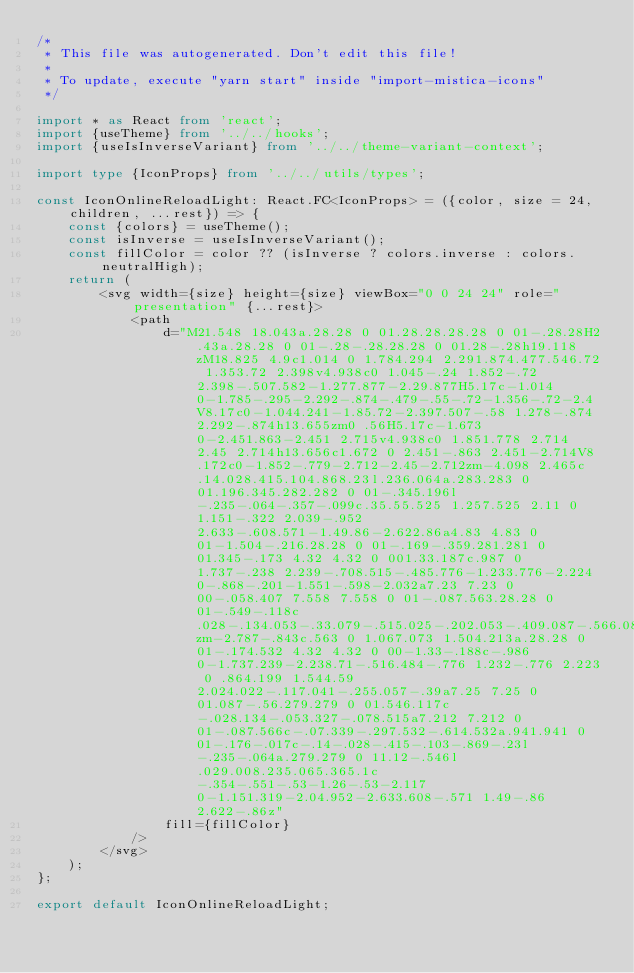Convert code to text. <code><loc_0><loc_0><loc_500><loc_500><_TypeScript_>/*
 * This file was autogenerated. Don't edit this file!
 *
 * To update, execute "yarn start" inside "import-mistica-icons"
 */

import * as React from 'react';
import {useTheme} from '../../hooks';
import {useIsInverseVariant} from '../../theme-variant-context';

import type {IconProps} from '../../utils/types';

const IconOnlineReloadLight: React.FC<IconProps> = ({color, size = 24, children, ...rest}) => {
    const {colors} = useTheme();
    const isInverse = useIsInverseVariant();
    const fillColor = color ?? (isInverse ? colors.inverse : colors.neutralHigh);
    return (
        <svg width={size} height={size} viewBox="0 0 24 24" role="presentation" {...rest}>
            <path
                d="M21.548 18.043a.28.28 0 01.28.28.28.28 0 01-.28.28H2.43a.28.28 0 01-.28-.28.28.28 0 01.28-.28h19.118zM18.825 4.9c1.014 0 1.784.294 2.291.874.477.546.72 1.353.72 2.398v4.938c0 1.045-.24 1.852-.72 2.398-.507.582-1.277.877-2.29.877H5.17c-1.014 0-1.785-.295-2.292-.874-.479-.55-.72-1.356-.72-2.4V8.17c0-1.044.241-1.85.72-2.397.507-.58 1.278-.874 2.292-.874h13.655zm0 .56H5.17c-1.673 0-2.451.863-2.451 2.715v4.938c0 1.851.778 2.714 2.45 2.714h13.656c1.672 0 2.451-.863 2.451-2.714V8.172c0-1.852-.779-2.712-2.45-2.712zm-4.098 2.465c.14.028.415.104.868.23l.236.064a.283.283 0 01.196.345.282.282 0 01-.345.196l-.235-.064-.357-.099c.35.55.525 1.257.525 2.11 0 1.151-.322 2.039-.952 2.633-.608.571-1.49.86-2.622.86a4.83 4.83 0 01-1.504-.216.28.28 0 01-.169-.359.281.281 0 01.345-.173 4.32 4.32 0 001.33.187c.987 0 1.737-.238 2.239-.708.515-.485.776-1.233.776-2.224 0-.868-.201-1.551-.598-2.032a7.23 7.23 0 00-.058.407 7.558 7.558 0 01-.087.563.28.28 0 01-.549-.118c.028-.134.053-.33.079-.515.025-.202.053-.409.087-.566.086-.406.386-.602.795-.52zm-2.787-.843c.563 0 1.067.073 1.504.213a.28.28 0 01-.174.532 4.32 4.32 0 00-1.33-.188c-.986 0-1.737.239-2.238.71-.516.484-.776 1.232-.776 2.223 0 .864.199 1.544.59 2.024.022-.117.041-.255.057-.39a7.25 7.25 0 01.087-.56.279.279 0 01.546.117c-.028.134-.053.327-.078.515a7.212 7.212 0 01-.087.566c-.07.339-.297.532-.614.532a.941.941 0 01-.176-.017c-.14-.028-.415-.103-.869-.23l-.235-.064a.279.279 0 11.12-.546l.029.008.235.065.365.1c-.354-.551-.53-1.26-.53-2.117 0-1.151.319-2.04.952-2.633.608-.571 1.49-.86 2.622-.86z"
                fill={fillColor}
            />
        </svg>
    );
};

export default IconOnlineReloadLight;
</code> 